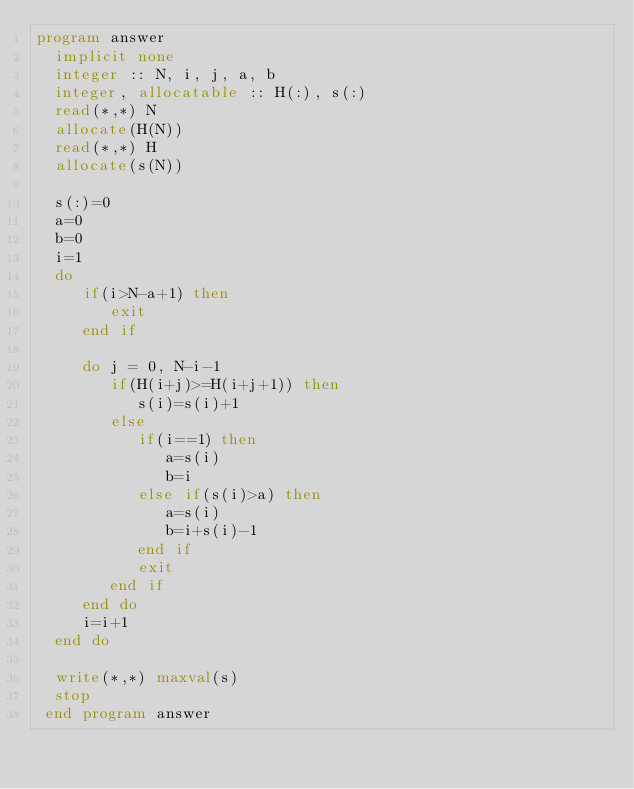Convert code to text. <code><loc_0><loc_0><loc_500><loc_500><_FORTRAN_>program answer
  implicit none
  integer :: N, i, j, a, b
  integer, allocatable :: H(:), s(:)
  read(*,*) N
  allocate(H(N))
  read(*,*) H
  allocate(s(N))

  s(:)=0
  a=0
  b=0
  i=1
  do
     if(i>N-a+1) then
        exit
     end if
     
     do j = 0, N-i-1
        if(H(i+j)>=H(i+j+1)) then
           s(i)=s(i)+1
        else
           if(i==1) then
              a=s(i)
              b=i
           else if(s(i)>a) then
              a=s(i)
              b=i+s(i)-1
           end if
           exit
        end if
     end do
     i=i+1
  end do

  write(*,*) maxval(s)
  stop
 end program answer
        </code> 